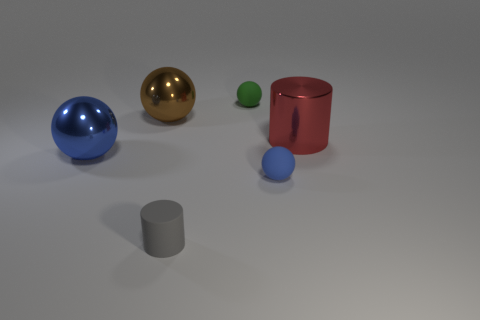Subtract all brown spheres. How many spheres are left? 3 Subtract all yellow spheres. Subtract all yellow cubes. How many spheres are left? 4 Add 1 big red metallic spheres. How many objects exist? 7 Subtract all cylinders. How many objects are left? 4 Add 6 small green balls. How many small green balls exist? 7 Subtract 0 purple blocks. How many objects are left? 6 Subtract all gray matte things. Subtract all large red metallic cylinders. How many objects are left? 4 Add 2 spheres. How many spheres are left? 6 